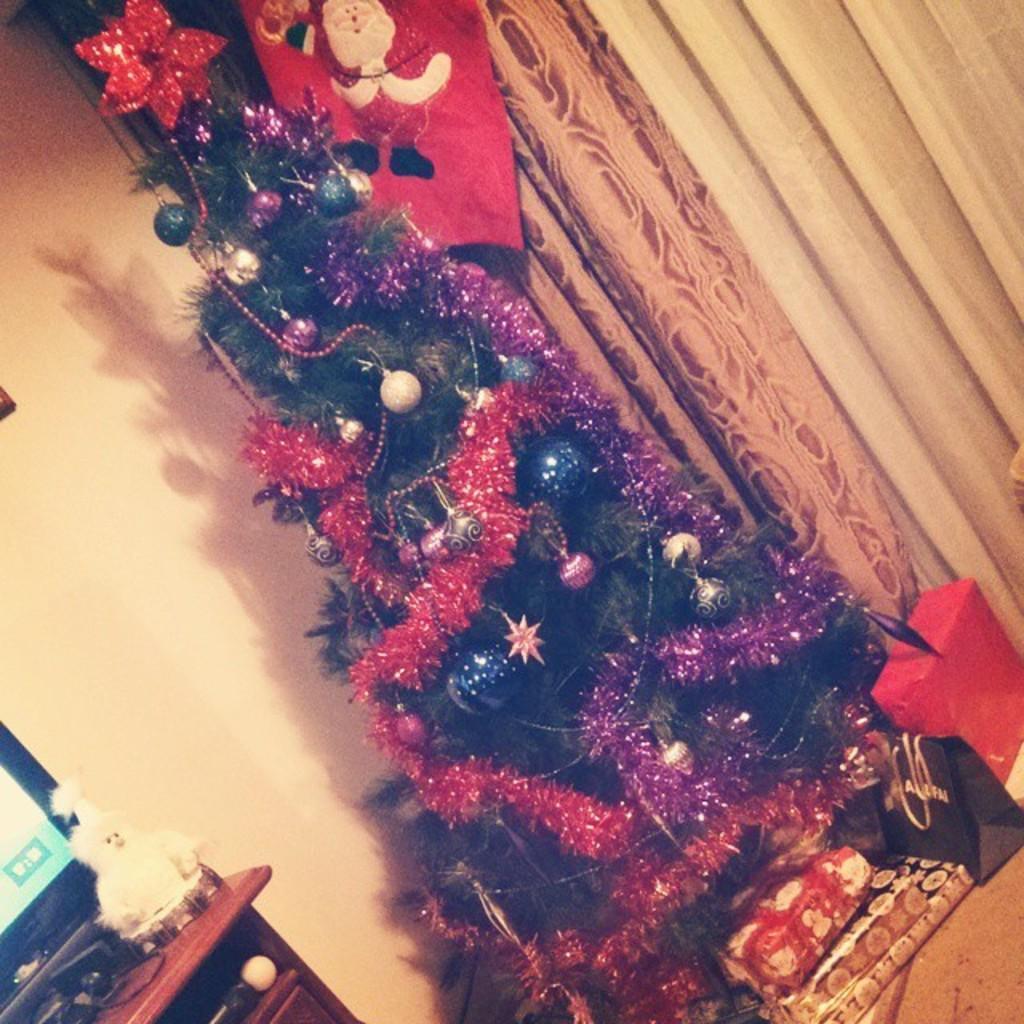Please provide a concise description of this image. There is a christmas tree which is decorated. There are gifts and carry bags. There is a table at the left on which there is a screen and a toy. There are curtains at the back. 